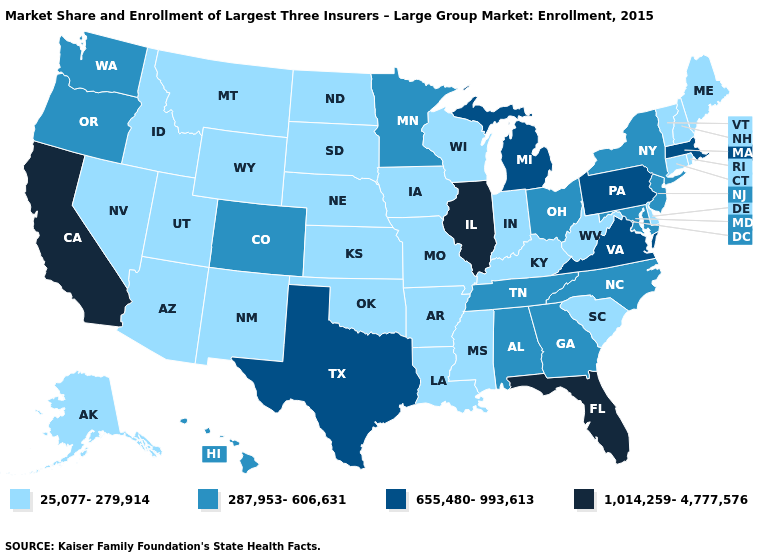Does Minnesota have the lowest value in the MidWest?
Give a very brief answer. No. Does Tennessee have the lowest value in the South?
Keep it brief. No. Does South Carolina have a higher value than Alabama?
Keep it brief. No. What is the value of Hawaii?
Concise answer only. 287,953-606,631. What is the highest value in states that border Nebraska?
Quick response, please. 287,953-606,631. What is the highest value in states that border Michigan?
Give a very brief answer. 287,953-606,631. What is the highest value in states that border Ohio?
Short answer required. 655,480-993,613. Does Arizona have a higher value than Arkansas?
Concise answer only. No. What is the highest value in the USA?
Give a very brief answer. 1,014,259-4,777,576. Does Minnesota have the highest value in the USA?
Be succinct. No. Name the states that have a value in the range 25,077-279,914?
Write a very short answer. Alaska, Arizona, Arkansas, Connecticut, Delaware, Idaho, Indiana, Iowa, Kansas, Kentucky, Louisiana, Maine, Mississippi, Missouri, Montana, Nebraska, Nevada, New Hampshire, New Mexico, North Dakota, Oklahoma, Rhode Island, South Carolina, South Dakota, Utah, Vermont, West Virginia, Wisconsin, Wyoming. Does New Mexico have the lowest value in the West?
Be succinct. Yes. Among the states that border West Virginia , which have the highest value?
Give a very brief answer. Pennsylvania, Virginia. What is the value of Oklahoma?
Short answer required. 25,077-279,914. What is the value of Iowa?
Answer briefly. 25,077-279,914. 